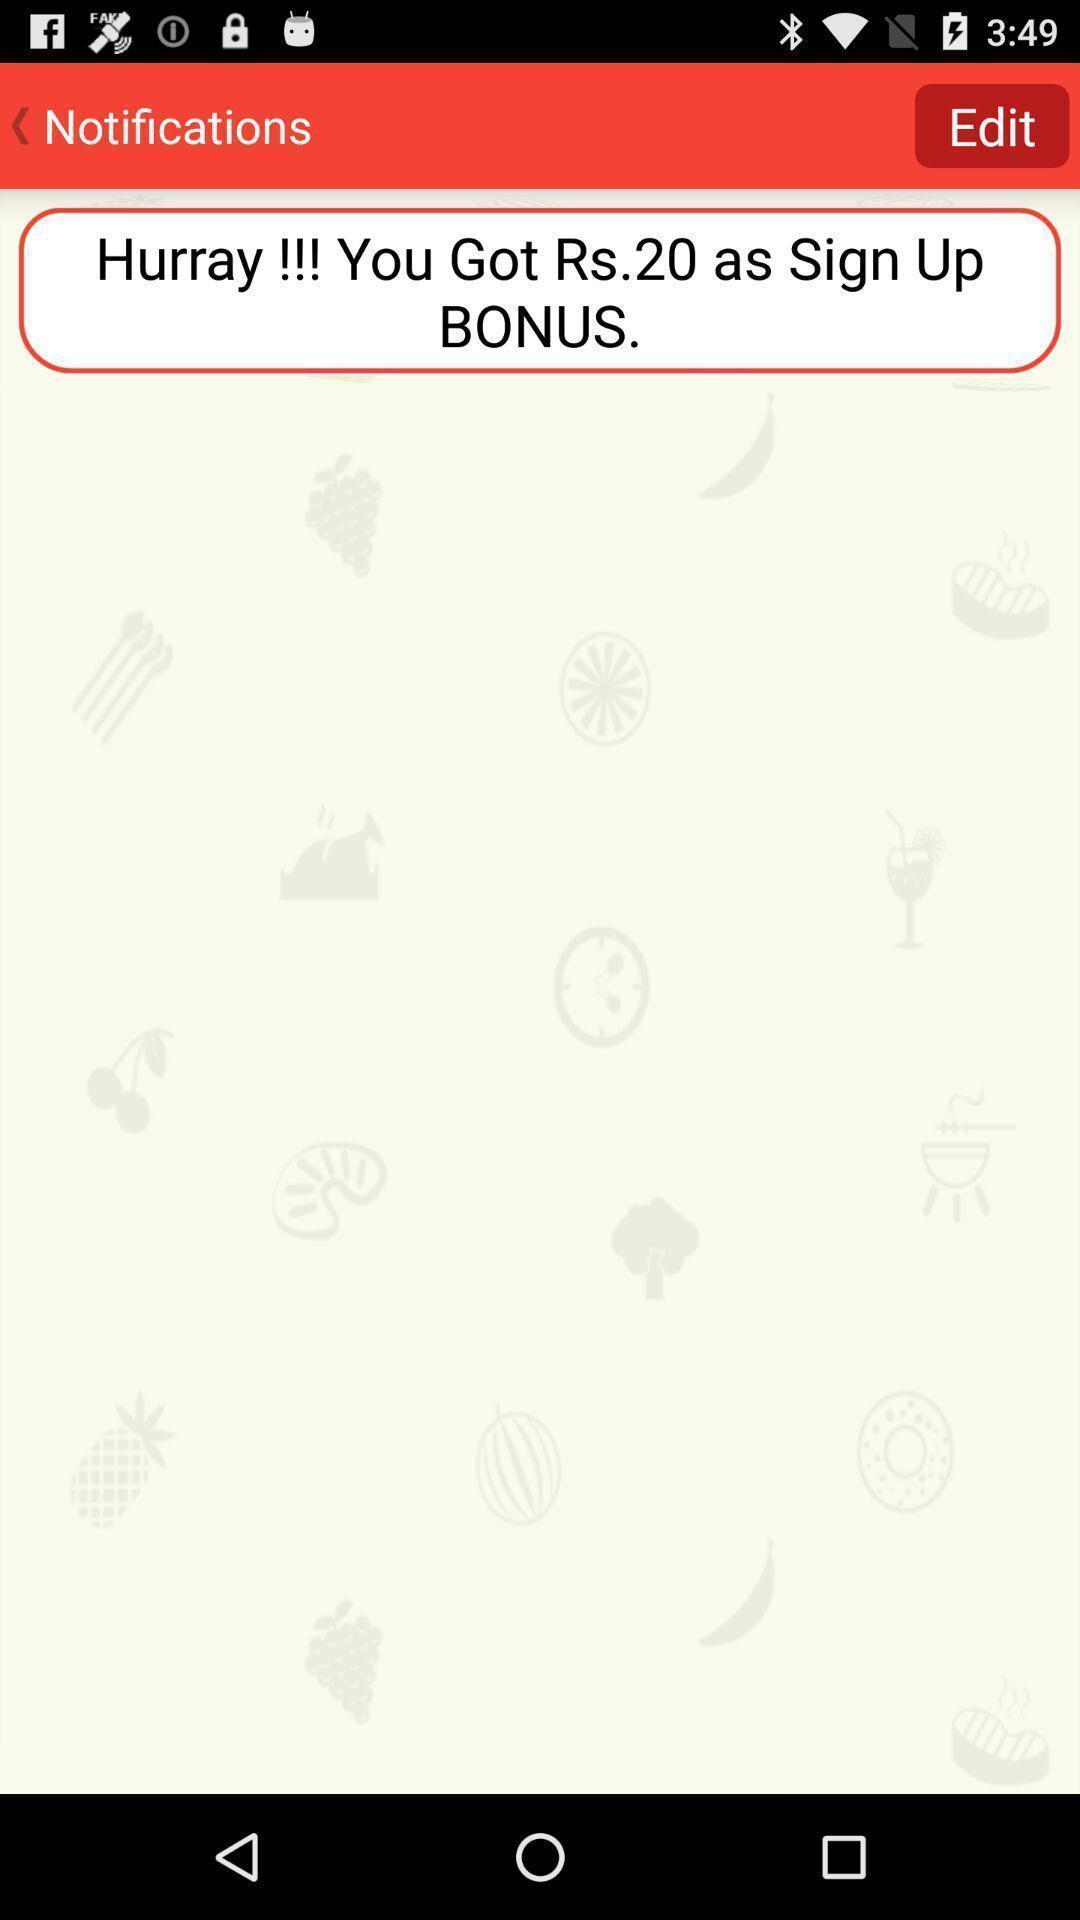Provide a description of this screenshot. Social app showing the notifications. 